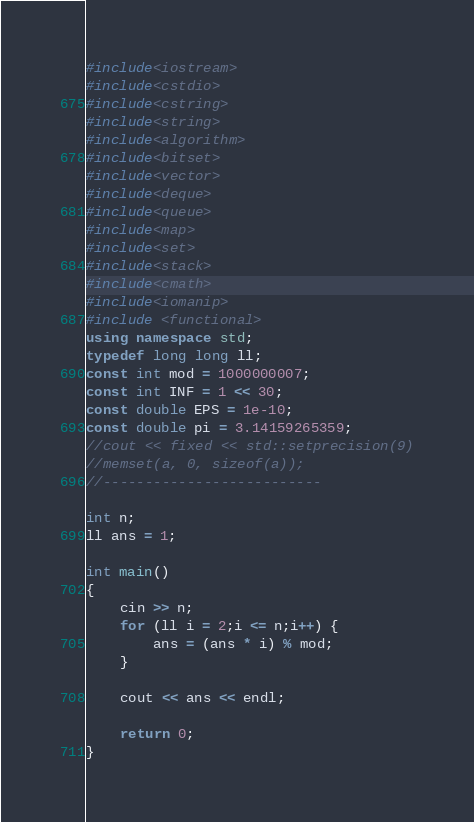<code> <loc_0><loc_0><loc_500><loc_500><_C++_>#include<iostream>
#include<cstdio>
#include<cstring>
#include<string>
#include<algorithm>
#include<bitset>
#include<vector>
#include<deque>
#include<queue>
#include<map>
#include<set>
#include<stack>
#include<cmath>
#include<iomanip>
#include <functional>
using namespace std;
typedef long long ll;
const int mod = 1000000007;
const int INF = 1 << 30;
const double EPS = 1e-10;
const double pi = 3.14159265359;
//cout << fixed << std::setprecision(9)
//memset(a, 0, sizeof(a));
//--------------------------

int n;
ll ans = 1;

int main()
{
	cin >> n;
	for (ll i = 2;i <= n;i++) {
		ans = (ans * i) % mod;
	}

	cout << ans << endl;

	return 0;
}
</code> 